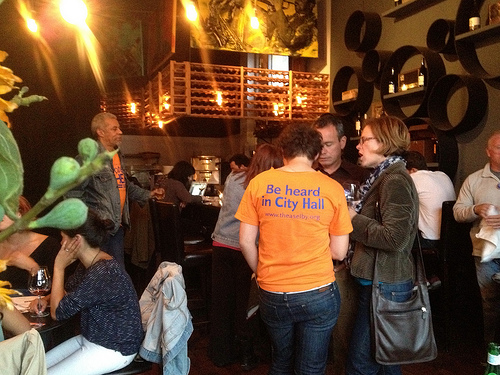<image>
Is there a man behind the seated woman? Yes. From this viewpoint, the man is positioned behind the seated woman, with the seated woman partially or fully occluding the man. 